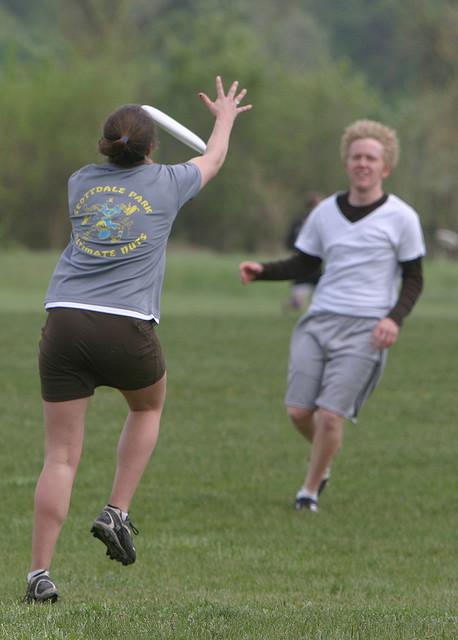What game are they playing?
Concise answer only. Frisbee. What color are the girl's shoes?
Be succinct. Black. What color is the Frisbee?
Give a very brief answer. White. How many people are playing?
Answer briefly. 2. How many women are there?
Write a very short answer. 1. How many of the women have stripes on their pants?
Short answer required. 1. What color are the girls sleeves?
Be succinct. Gray. What sport are these people playing?
Keep it brief. Frisbee. Is it summer?
Concise answer only. Yes. Is she wearing cleats?
Quick response, please. Yes. Are the player's laces wrapped under her cleats?
Answer briefly. No. Will there be an injury?
Keep it brief. No. What sport is he playing?
Answer briefly. Frisbee. What sport is being played?
Write a very short answer. Frisbee. What do Americans call this sport?
Give a very brief answer. Frisbee. What game is this?
Give a very brief answer. Frisbee. What sport is this?
Be succinct. Frisbee. Which man caught the disk?
Write a very short answer. Woman. How many people are playing frisbee?
Be succinct. 2. What sport are they playing?
Answer briefly. Frisbee. 